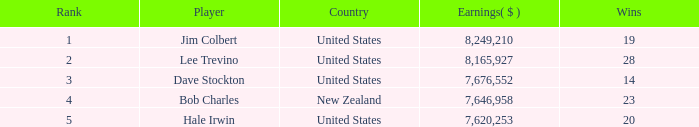How much money have players made who have 14 wins and are ranked lower than 3? 0.0. 